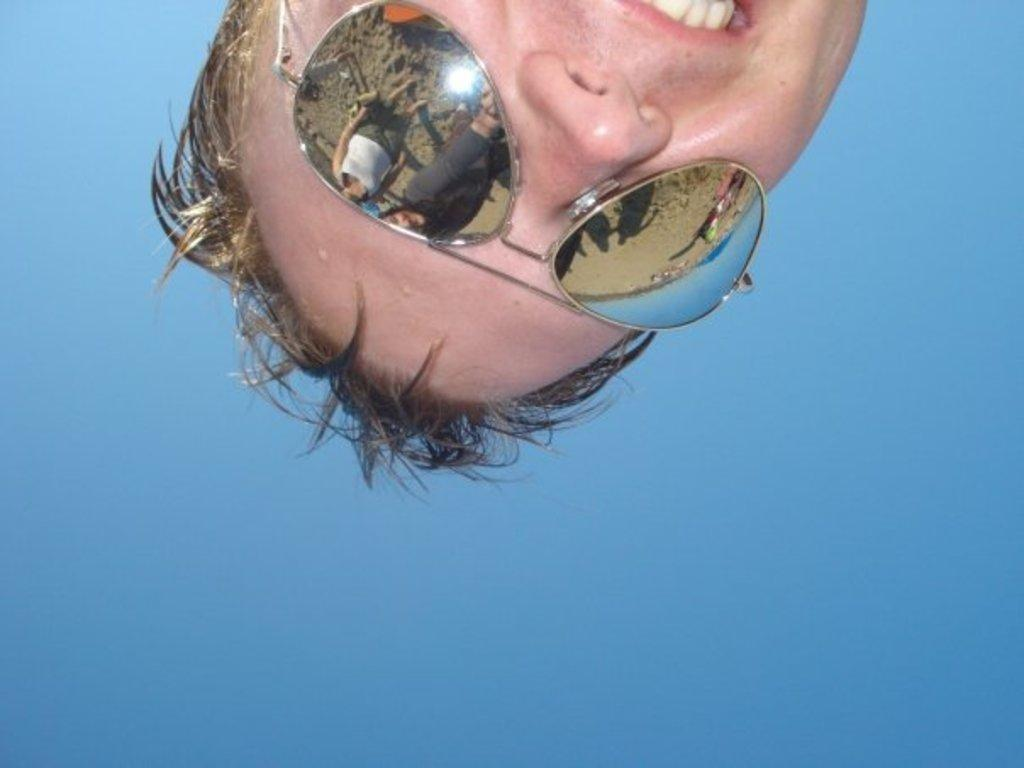What can be seen in the image? There is a person in the image. What is the person wearing? The person is wearing goggles. What expression does the person have? The person is smiling. What can be seen on the goggles? There is a reflection of people on the goggles. What is visible in the background of the image? The sky is visible in the background of the image. How many children are playing with salt in the image? There are no children or salt present in the image. What type of space vehicle can be seen in the image? There is no space vehicle present in the image. 